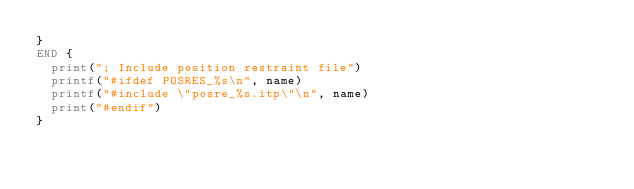Convert code to text. <code><loc_0><loc_0><loc_500><loc_500><_Awk_>}
END {
  print("; Include position restraint file")
  printf("#ifdef POSRES_%s\n", name)
  printf("#include \"posre_%s.itp\"\n", name)
  print("#endif")
}
</code> 